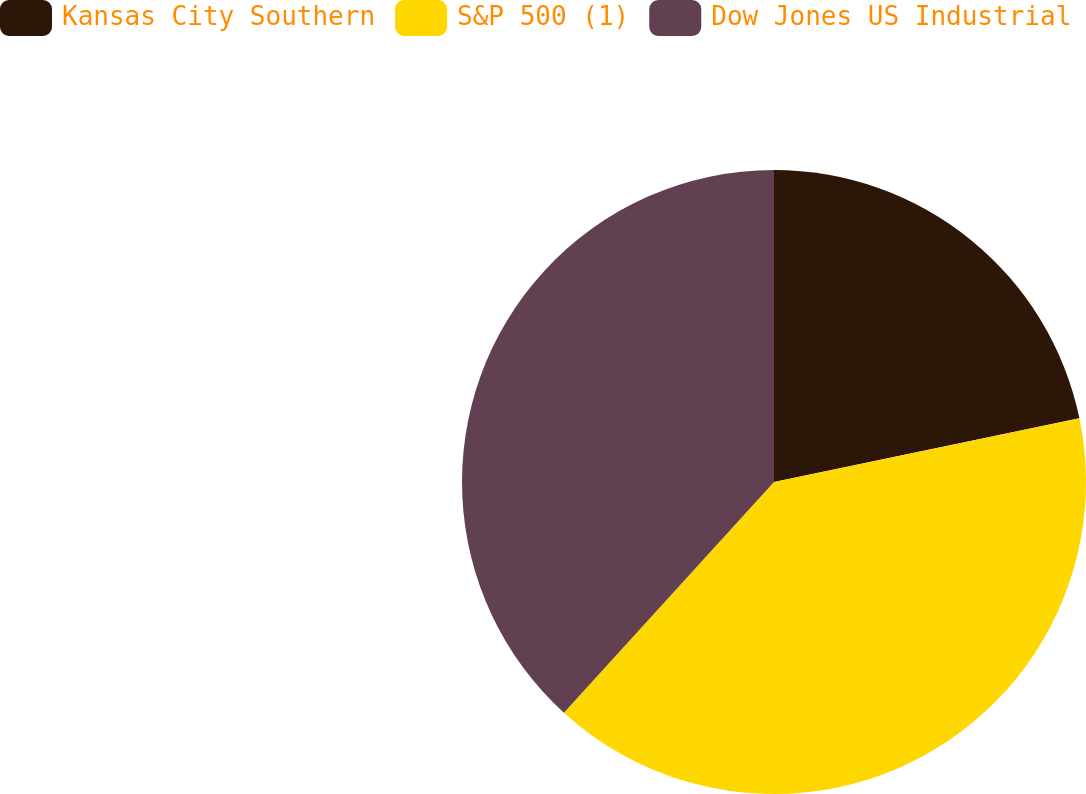Convert chart to OTSL. <chart><loc_0><loc_0><loc_500><loc_500><pie_chart><fcel>Kansas City Southern<fcel>S&P 500 (1)<fcel>Dow Jones US Industrial<nl><fcel>21.73%<fcel>40.03%<fcel>38.24%<nl></chart> 